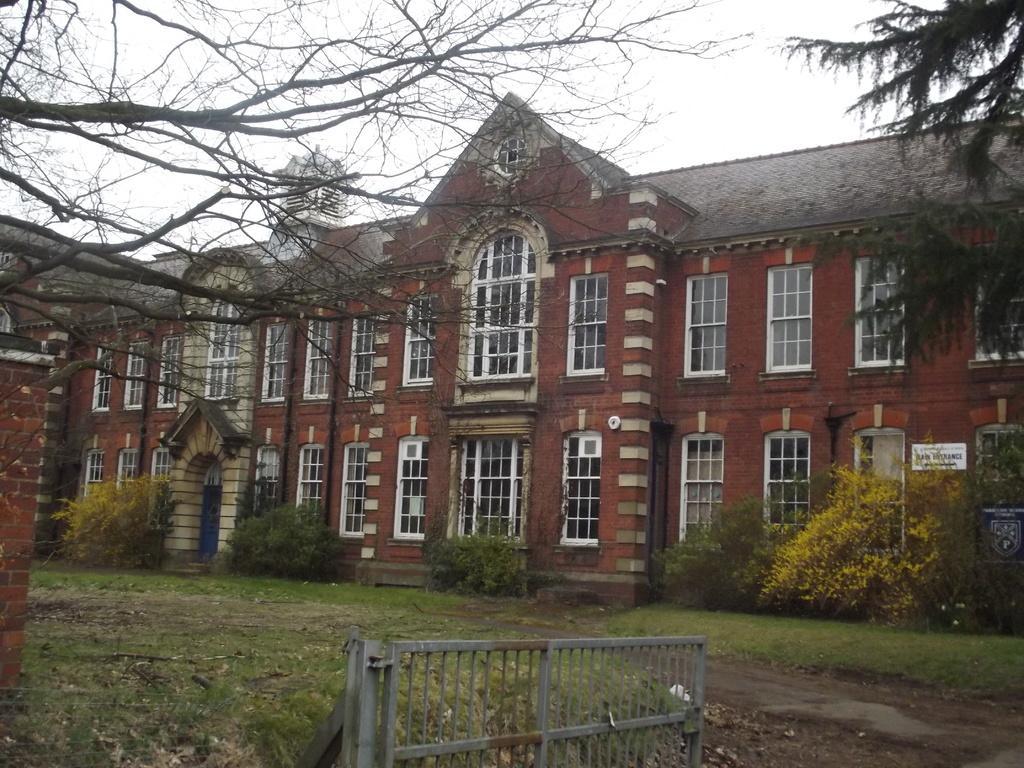How would you summarize this image in a sentence or two? In this image I can see the building which is in brown color. In-front of the building I can see many plants, broad and also the railing. In the back I can see trees and the white sky. 